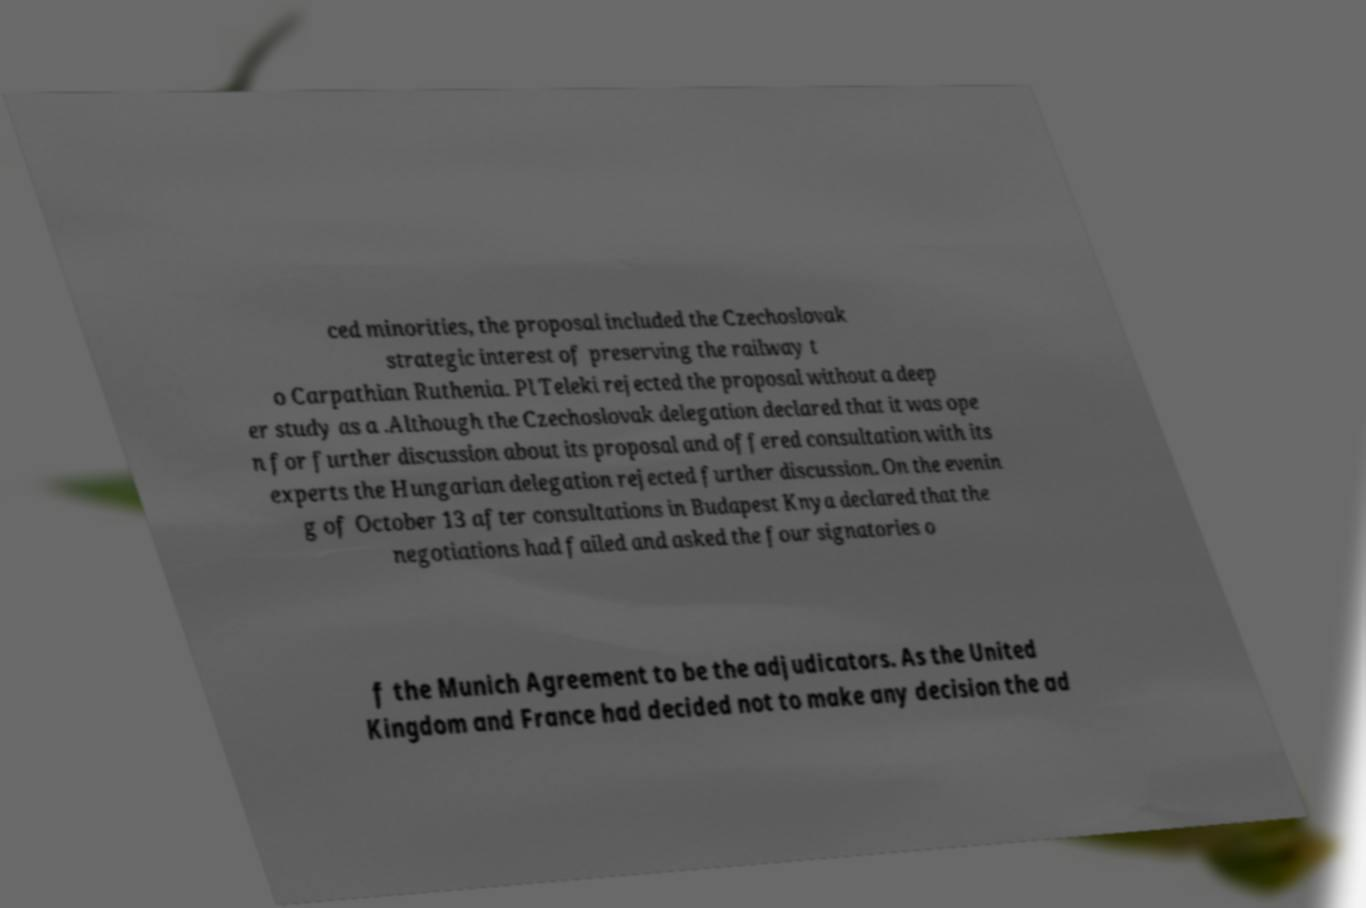What messages or text are displayed in this image? I need them in a readable, typed format. ced minorities, the proposal included the Czechoslovak strategic interest of preserving the railway t o Carpathian Ruthenia. Pl Teleki rejected the proposal without a deep er study as a .Although the Czechoslovak delegation declared that it was ope n for further discussion about its proposal and offered consultation with its experts the Hungarian delegation rejected further discussion. On the evenin g of October 13 after consultations in Budapest Knya declared that the negotiations had failed and asked the four signatories o f the Munich Agreement to be the adjudicators. As the United Kingdom and France had decided not to make any decision the ad 